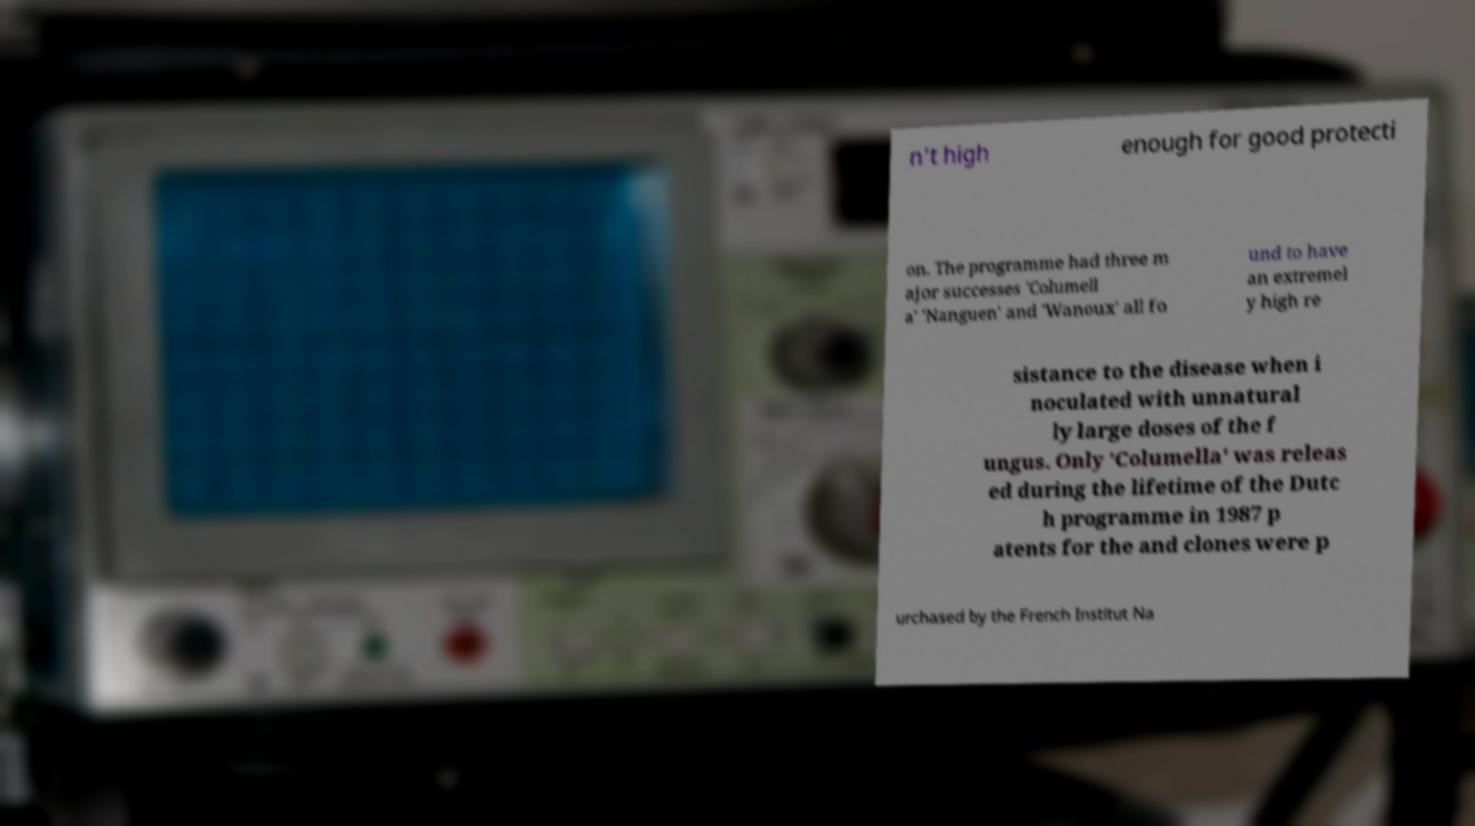Could you extract and type out the text from this image? n't high enough for good protecti on. The programme had three m ajor successes 'Columell a' 'Nanguen' and 'Wanoux' all fo und to have an extremel y high re sistance to the disease when i noculated with unnatural ly large doses of the f ungus. Only 'Columella' was releas ed during the lifetime of the Dutc h programme in 1987 p atents for the and clones were p urchased by the French Institut Na 